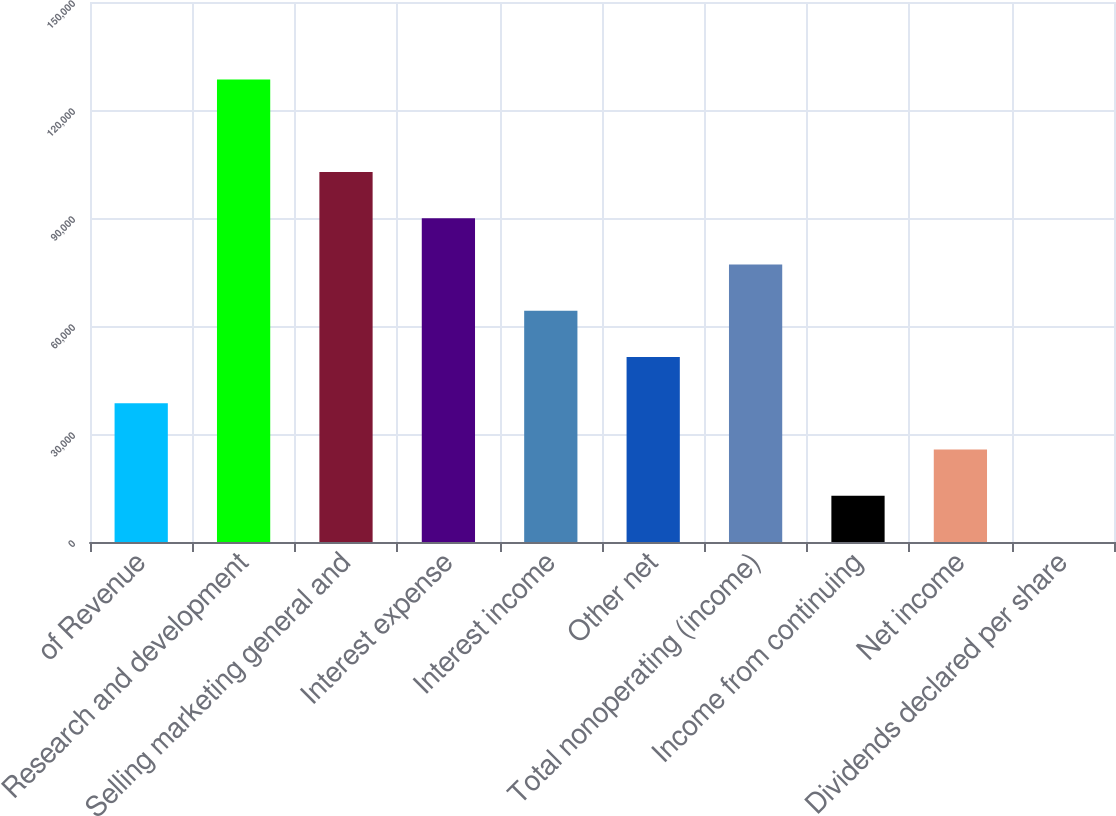Convert chart. <chart><loc_0><loc_0><loc_500><loc_500><bar_chart><fcel>of Revenue<fcel>Research and development<fcel>Selling marketing general and<fcel>Interest expense<fcel>Interest income<fcel>Other net<fcel>Total nonoperating (income)<fcel>Income from continuing<fcel>Net income<fcel>Dividends declared per share<nl><fcel>38543<fcel>128476<fcel>102781<fcel>89933.3<fcel>64238.1<fcel>51390.6<fcel>77085.7<fcel>12847.8<fcel>25695.4<fcel>0.25<nl></chart> 